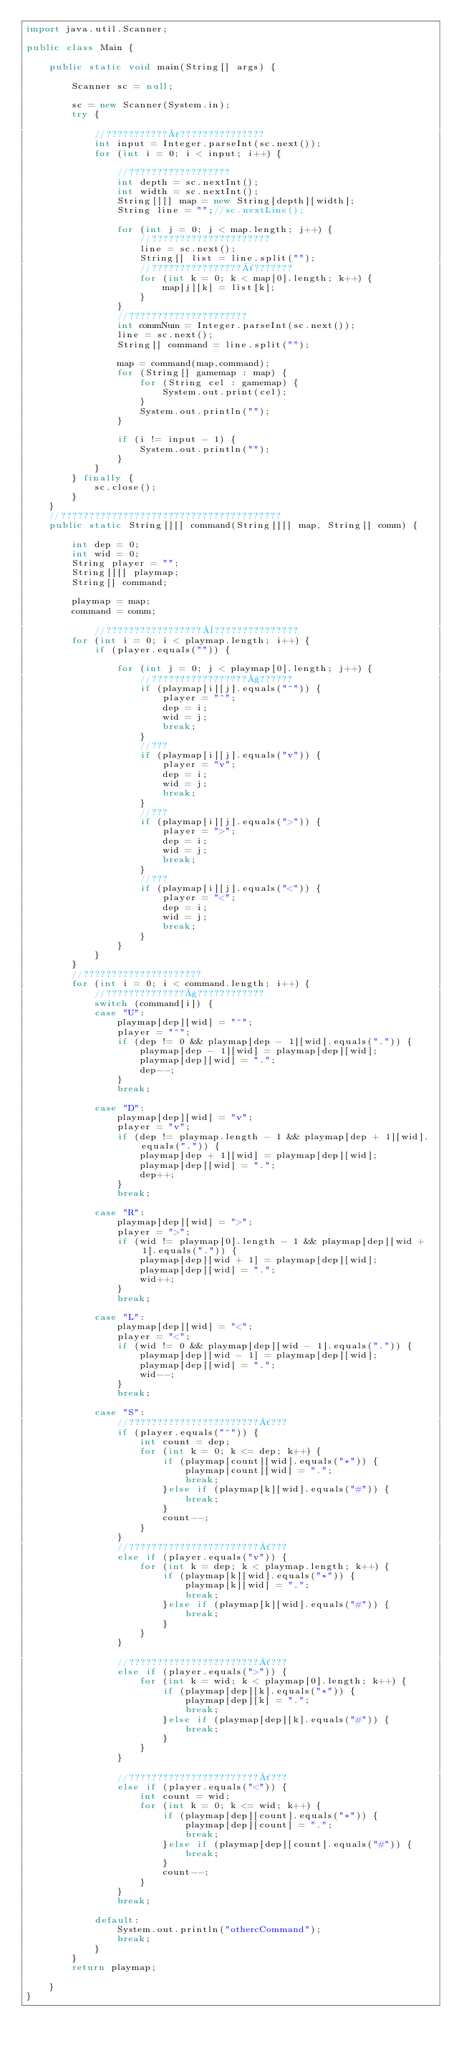Convert code to text. <code><loc_0><loc_0><loc_500><loc_500><_Java_>import java.util.Scanner;

public class Main {

	public static void main(String[] args) {

		Scanner sc = null;

		sc = new Scanner(System.in);
		try {

			//???????????°???????????????
			int input = Integer.parseInt(sc.next());
			for (int i = 0; i < input; i++) {

				//??????????????????
				int depth = sc.nextInt();
				int width = sc.nextInt();
				String[][] map = new String[depth][width];
				String line = "";//sc.nextLine();

				for (int j = 0; j < map.length; j++) {
					//?????????????????????
					line = sc.next();
					String[] list = line.split("");
					//????????????????´???????
					for (int k = 0; k < map[0].length; k++) {
						map[j][k] = list[k];
					}
				}
				//?????????????????????
				int commNum = Integer.parseInt(sc.next());
				line = sc.next();
				String[] command = line.split("");

				map = command(map,command);
				for (String[] gamemap : map) {
					for (String cel : gamemap) {
						System.out.print(cel);
					}
					System.out.println("");
				}

				if (i != input - 1) {
					System.out.println("");
				}
			}
		} finally {
			sc.close();
		}
	}
	//???????????????????????????????????????
	public static String[][] command(String[][] map, String[] comm) {

		int dep = 0;
		int wid = 0;
		String player = "";
		String[][] playmap;
		String[] command;

		playmap = map;
		command = comm;

			//?????????????????¨???????????????
		for (int i = 0; i < playmap.length; i++) {
			if (player.equals("")) {

				for (int j = 0; j < playmap[0].length; j++) {
					//?????????????????§??????
					if (playmap[i][j].equals("^")) {
						player = "^";
						dep = i;
						wid = j;
						break;
					}
					//???
					if (playmap[i][j].equals("v")) {
						player = "v";
						dep = i;
						wid = j;
						break;
					}
					//???
					if (playmap[i][j].equals(">")) {
						player = ">";
						dep = i;
						wid = j;
						break;
					}
					//???
					if (playmap[i][j].equals("<")) {
						player = "<";
						dep = i;
						wid = j;
						break;
					}
				}
			}
		}
		//?????????????????????
		for (int i = 0; i < command.length; i++) {
			//??????????????§????????????
			switch (command[i]) {
			case "U":
				playmap[dep][wid] = "^";
				player = "^";
				if (dep != 0 && playmap[dep - 1][wid].equals(".")) {
					playmap[dep - 1][wid] = playmap[dep][wid];
					playmap[dep][wid] = ".";
					dep--;
				}
				break;

			case "D":
				playmap[dep][wid] = "v";
				player = "v";
				if (dep != playmap.length - 1 && playmap[dep + 1][wid].equals(".")) {
					playmap[dep + 1][wid] = playmap[dep][wid];
					playmap[dep][wid] = ".";
					dep++;
				}
				break;

			case "R":
				playmap[dep][wid] = ">";
				player = ">";
				if (wid != playmap[0].length - 1 && playmap[dep][wid + 1].equals(".")) {
					playmap[dep][wid + 1] = playmap[dep][wid];
					playmap[dep][wid] = ".";
					wid++;
				}
				break;

			case "L":
				playmap[dep][wid] = "<";
				player = "<";
				if (wid != 0 && playmap[dep][wid - 1].equals(".")) {
					playmap[dep][wid - 1] = playmap[dep][wid];
					playmap[dep][wid] = ".";
					wid--;
				}
				break;

			case "S":
				//???????????????????????´???
				if (player.equals("^")) {
					int count = dep;
					for (int k = 0; k <= dep; k++) {
						if (playmap[count][wid].equals("*")) {
							playmap[count][wid] = ".";
							break;
						}else if (playmap[k][wid].equals("#")) {
							break;
						}
						count--;
					}
				}
				//???????????????????????´???
				else if (player.equals("v")) {
					for (int k = dep; k < playmap.length; k++) {
						if (playmap[k][wid].equals("*")) {
							playmap[k][wid] = ".";
							break;
						}else if (playmap[k][wid].equals("#")) {
							break;
						}
					}
				}

				//???????????????????????´???
				else if (player.equals(">")) {
					for (int k = wid; k < playmap[0].length; k++) {
						if (playmap[dep][k].equals("*")) {
							playmap[dep][k] = ".";
							break;
						}else if (playmap[dep][k].equals("#")) {
							break;
						}
					}
				}

				//???????????????????????´???
				else if (player.equals("<")) {
					int count = wid;
					for (int k = 0; k <= wid; k++) {
						if (playmap[dep][count].equals("*")) {
							playmap[dep][count] = ".";
							break;
						}else if (playmap[dep][count].equals("#")) {
							break;
						}
						count--;
					}
				}
				break;

			default:
				System.out.println("othercCommand");
				break;
			}
		}
		return playmap;

	}
}</code> 